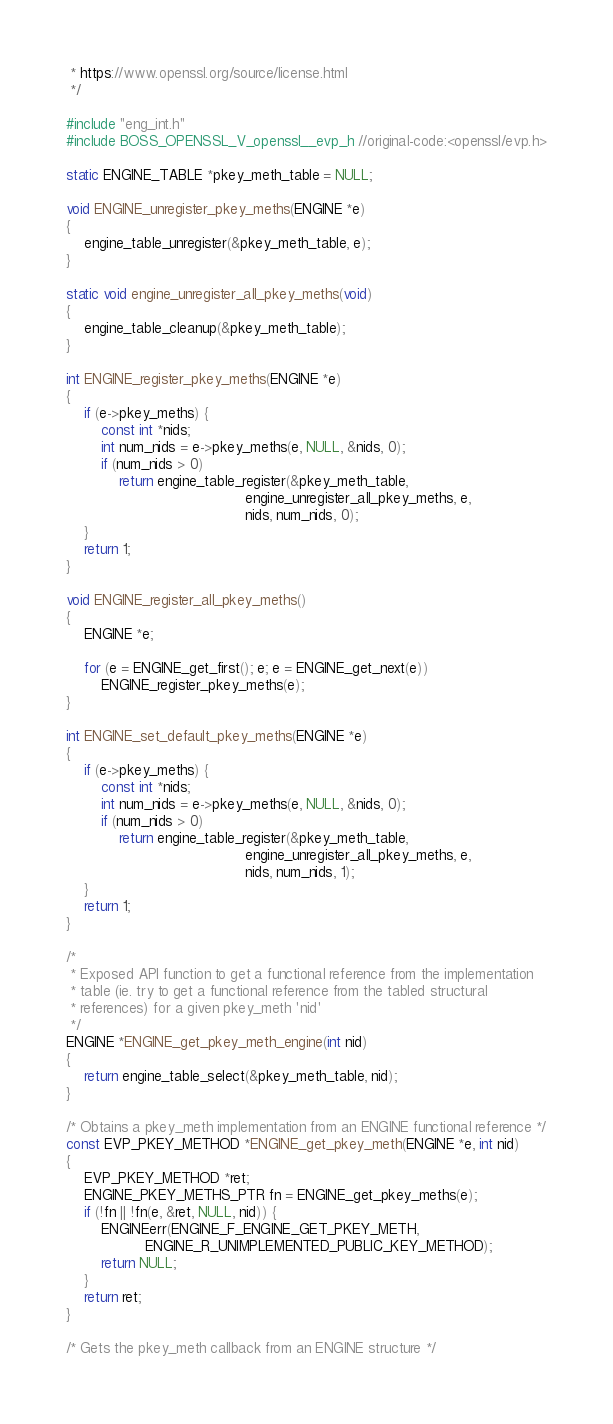Convert code to text. <code><loc_0><loc_0><loc_500><loc_500><_C_> * https://www.openssl.org/source/license.html
 */

#include "eng_int.h"
#include BOSS_OPENSSL_V_openssl__evp_h //original-code:<openssl/evp.h>

static ENGINE_TABLE *pkey_meth_table = NULL;

void ENGINE_unregister_pkey_meths(ENGINE *e)
{
    engine_table_unregister(&pkey_meth_table, e);
}

static void engine_unregister_all_pkey_meths(void)
{
    engine_table_cleanup(&pkey_meth_table);
}

int ENGINE_register_pkey_meths(ENGINE *e)
{
    if (e->pkey_meths) {
        const int *nids;
        int num_nids = e->pkey_meths(e, NULL, &nids, 0);
        if (num_nids > 0)
            return engine_table_register(&pkey_meth_table,
                                         engine_unregister_all_pkey_meths, e,
                                         nids, num_nids, 0);
    }
    return 1;
}

void ENGINE_register_all_pkey_meths()
{
    ENGINE *e;

    for (e = ENGINE_get_first(); e; e = ENGINE_get_next(e))
        ENGINE_register_pkey_meths(e);
}

int ENGINE_set_default_pkey_meths(ENGINE *e)
{
    if (e->pkey_meths) {
        const int *nids;
        int num_nids = e->pkey_meths(e, NULL, &nids, 0);
        if (num_nids > 0)
            return engine_table_register(&pkey_meth_table,
                                         engine_unregister_all_pkey_meths, e,
                                         nids, num_nids, 1);
    }
    return 1;
}

/*
 * Exposed API function to get a functional reference from the implementation
 * table (ie. try to get a functional reference from the tabled structural
 * references) for a given pkey_meth 'nid'
 */
ENGINE *ENGINE_get_pkey_meth_engine(int nid)
{
    return engine_table_select(&pkey_meth_table, nid);
}

/* Obtains a pkey_meth implementation from an ENGINE functional reference */
const EVP_PKEY_METHOD *ENGINE_get_pkey_meth(ENGINE *e, int nid)
{
    EVP_PKEY_METHOD *ret;
    ENGINE_PKEY_METHS_PTR fn = ENGINE_get_pkey_meths(e);
    if (!fn || !fn(e, &ret, NULL, nid)) {
        ENGINEerr(ENGINE_F_ENGINE_GET_PKEY_METH,
                  ENGINE_R_UNIMPLEMENTED_PUBLIC_KEY_METHOD);
        return NULL;
    }
    return ret;
}

/* Gets the pkey_meth callback from an ENGINE structure */</code> 